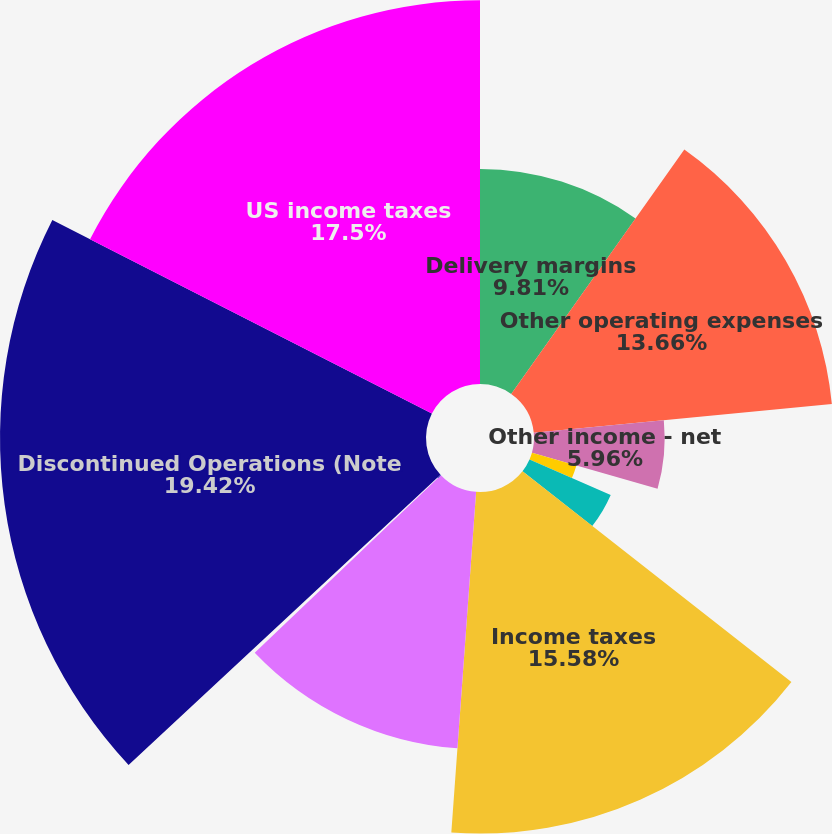Convert chart to OTSL. <chart><loc_0><loc_0><loc_500><loc_500><pie_chart><fcel>Delivery margins<fcel>Other operating expenses<fcel>Other income - net<fcel>Depreciation<fcel>Interest expense<fcel>Income taxes<fcel>Foreign currency exchange<fcel>Other<fcel>Discontinued Operations (Note<fcel>US income taxes<nl><fcel>9.81%<fcel>13.66%<fcel>5.96%<fcel>2.11%<fcel>4.04%<fcel>15.58%<fcel>11.73%<fcel>0.19%<fcel>19.43%<fcel>17.5%<nl></chart> 